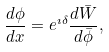<formula> <loc_0><loc_0><loc_500><loc_500>\frac { d \phi } { d x } = e ^ { \imath \delta } \frac { d \bar { W } } { d \bar { \phi } } ,</formula> 